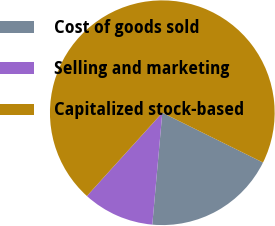<chart> <loc_0><loc_0><loc_500><loc_500><pie_chart><fcel>Cost of goods sold<fcel>Selling and marketing<fcel>Capitalized stock-based<nl><fcel>19.11%<fcel>10.29%<fcel>70.6%<nl></chart> 